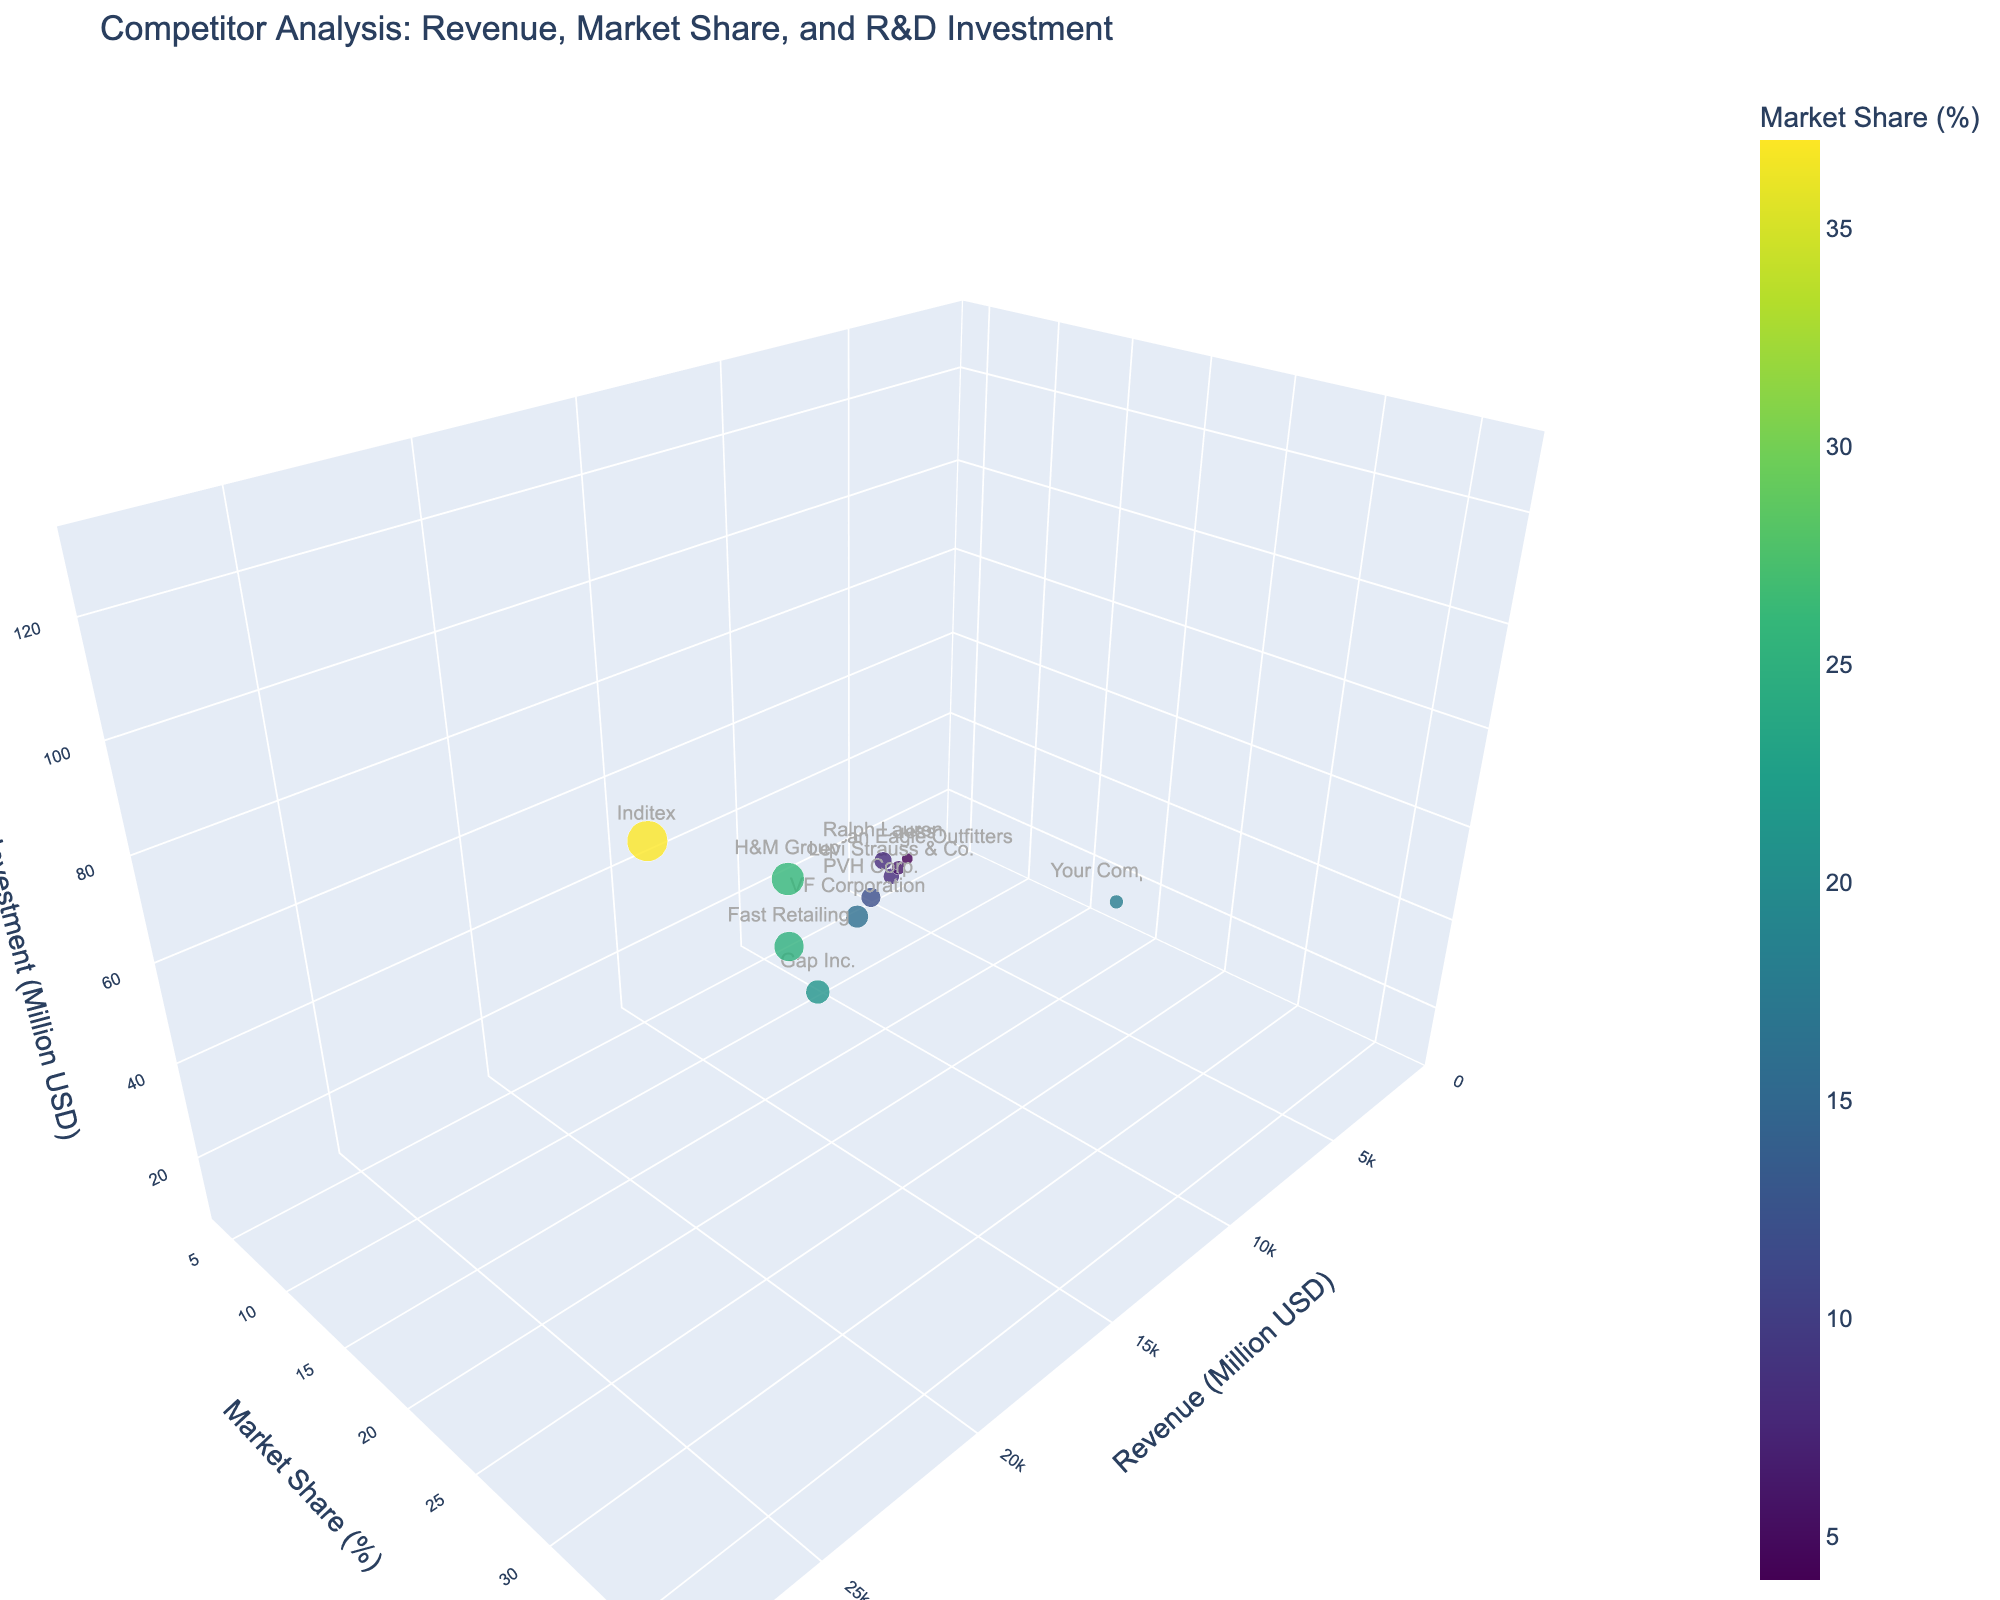what is the total number of companies represented in the figure? There are individual data points for each company on the 3D bubble chart. By counting the distinct bubbles, we can determine the number of companies. Each bubble represents one company.
Answer: 11 Which company has the highest revenue? By looking at the x-axis labeled "Revenue (Million USD)" and identifying the bubble furthest to the right, we can determine which company has the highest revenue. Inditex is the furthest to the right, indicating the highest revenue.
Answer: Inditex How does your company's R&D investment compare to Gap Inc.'s? By comparing the z-axis values for "Your Company" and "Gap Inc.," we can determine the R&D investment for each. "Your Company" has an R&D investment of $15 million, while Gap Inc. has $45 million. Gap Inc.'s R&D investment is higher.
Answer: Gap Inc. has higher R&D investment What is the average market share of the companies with revenue above $10,000 million? First, identify companies with revenue above $10,000 million: Inditex, H&M Group, Fast Retailing, Gap Inc., PVH Corp., and VF Corporation. Then, sum their market shares (37% + 26% + 25% + 21% + 12% + 16%) and divide by the number of companies (6). Average market share = (37 + 26 + 25 + 21 + 12 + 16) / 6 = 22.83%.
Answer: 22.83% Which company has the lowest market share and what is its revenue? By looking at the y-axis labeled "Market Share (%)" and identifying the bubble lowest on the chart, we can determine which company has the lowest market share. Guess is the lowest with a market share of 4%. Its corresponding x-axis value shows a revenue of $2700 million.
Answer: Guess, $2700 million Comparing the bubble sizes, which company invests the most in R&D? The size of the bubble correlates with the R&D investment. The largest bubble represents the highest R&D investment. Inditex has the largest bubble, indicating the highest R&D investment.
Answer: Inditex Do companies with higher revenues generally have higher R&D investments? Observing the diagonal trend from the bottom-left to the top-right in the 3D space, we can deduce that companies with higher revenues tend to have higher R&D investments (e.g., Inditex, H&M Group, Fast Retailing).
Answer: Yes What is the difference in market share between H&M Group and VF Corporation? Compare their positions on the y-axis: H&M Group has a market share of 26%, and VF Corporation has 16%. Difference = 26% - 16% = 10%.
Answer: 10% Which companies have a similar market share to your company, and what are their R&D investments? "Your Company" has a market share of 18%. Companies with close market shares are PVH Corp. (12%) and VF Corporation (16%). PVH Corp.'s R&D investment is $30 million, and VF Corporation's is $40 million.
Answer: PVH Corp.: $30 million, VF Corporation: $40 million What is the relationship between market share and R&D investment based on the colors of the bubbles? Colors represent market share. Generally, bubbles with higher R&D investments are also in the color range representing higher market shares, indicating a positive relationship between higher R&D investment and greater market share (e.g., Inditex, H&M Group).
Answer: Positive relationship 